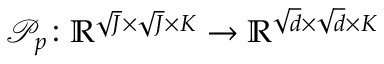Convert formula to latex. <formula><loc_0><loc_0><loc_500><loc_500>\mathcal { P } _ { p } \colon \mathbb { R } ^ { \sqrt { J } \times \sqrt { J } \times K } \to \mathbb { R } ^ { \sqrt { d } \times \sqrt { d } \times K }</formula> 